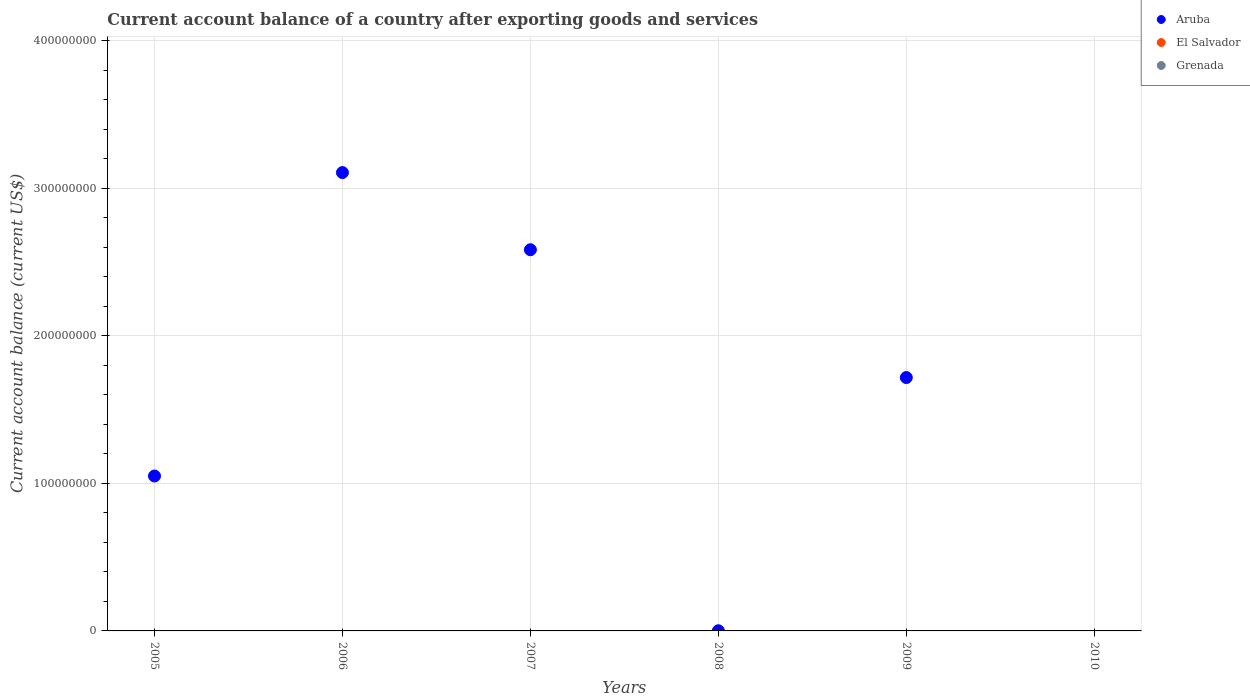Is the number of dotlines equal to the number of legend labels?
Offer a terse response. No. What is the account balance in Aruba in 2008?
Provide a short and direct response. 1.12e+05. Across all years, what is the maximum account balance in Aruba?
Your answer should be very brief. 3.11e+08. Across all years, what is the minimum account balance in El Salvador?
Ensure brevity in your answer.  0. What is the total account balance in Grenada in the graph?
Your answer should be compact. 0. What is the difference between the account balance in Aruba in 2008 and the account balance in El Salvador in 2007?
Give a very brief answer. 1.12e+05. What is the average account balance in Aruba per year?
Make the answer very short. 1.41e+08. In how many years, is the account balance in Grenada greater than 260000000 US$?
Give a very brief answer. 0. What is the ratio of the account balance in Aruba in 2008 to that in 2009?
Your answer should be compact. 0. What is the difference between the highest and the second highest account balance in Aruba?
Provide a short and direct response. 5.23e+07. What is the difference between the highest and the lowest account balance in Aruba?
Offer a terse response. 3.11e+08. Does the account balance in Aruba monotonically increase over the years?
Your answer should be compact. No. Is the account balance in Grenada strictly less than the account balance in Aruba over the years?
Offer a very short reply. No. Does the graph contain grids?
Ensure brevity in your answer.  Yes. How many legend labels are there?
Your answer should be compact. 3. What is the title of the graph?
Make the answer very short. Current account balance of a country after exporting goods and services. What is the label or title of the X-axis?
Ensure brevity in your answer.  Years. What is the label or title of the Y-axis?
Offer a terse response. Current account balance (current US$). What is the Current account balance (current US$) of Aruba in 2005?
Provide a succinct answer. 1.05e+08. What is the Current account balance (current US$) in El Salvador in 2005?
Keep it short and to the point. 0. What is the Current account balance (current US$) of Grenada in 2005?
Provide a succinct answer. 0. What is the Current account balance (current US$) of Aruba in 2006?
Your response must be concise. 3.11e+08. What is the Current account balance (current US$) of El Salvador in 2006?
Your answer should be compact. 0. What is the Current account balance (current US$) of Grenada in 2006?
Give a very brief answer. 0. What is the Current account balance (current US$) in Aruba in 2007?
Your answer should be compact. 2.58e+08. What is the Current account balance (current US$) of Grenada in 2007?
Keep it short and to the point. 0. What is the Current account balance (current US$) in Aruba in 2008?
Provide a succinct answer. 1.12e+05. What is the Current account balance (current US$) in Aruba in 2009?
Keep it short and to the point. 1.72e+08. What is the Current account balance (current US$) in Grenada in 2009?
Your response must be concise. 0. Across all years, what is the maximum Current account balance (current US$) in Aruba?
Provide a succinct answer. 3.11e+08. Across all years, what is the minimum Current account balance (current US$) of Aruba?
Offer a terse response. 0. What is the total Current account balance (current US$) in Aruba in the graph?
Provide a short and direct response. 8.46e+08. What is the total Current account balance (current US$) in Grenada in the graph?
Give a very brief answer. 0. What is the difference between the Current account balance (current US$) of Aruba in 2005 and that in 2006?
Provide a succinct answer. -2.06e+08. What is the difference between the Current account balance (current US$) in Aruba in 2005 and that in 2007?
Provide a short and direct response. -1.53e+08. What is the difference between the Current account balance (current US$) of Aruba in 2005 and that in 2008?
Keep it short and to the point. 1.05e+08. What is the difference between the Current account balance (current US$) in Aruba in 2005 and that in 2009?
Ensure brevity in your answer.  -6.67e+07. What is the difference between the Current account balance (current US$) of Aruba in 2006 and that in 2007?
Keep it short and to the point. 5.23e+07. What is the difference between the Current account balance (current US$) in Aruba in 2006 and that in 2008?
Make the answer very short. 3.10e+08. What is the difference between the Current account balance (current US$) in Aruba in 2006 and that in 2009?
Your answer should be very brief. 1.39e+08. What is the difference between the Current account balance (current US$) of Aruba in 2007 and that in 2008?
Keep it short and to the point. 2.58e+08. What is the difference between the Current account balance (current US$) in Aruba in 2007 and that in 2009?
Keep it short and to the point. 8.66e+07. What is the difference between the Current account balance (current US$) of Aruba in 2008 and that in 2009?
Provide a succinct answer. -1.72e+08. What is the average Current account balance (current US$) of Aruba per year?
Keep it short and to the point. 1.41e+08. What is the average Current account balance (current US$) of Grenada per year?
Keep it short and to the point. 0. What is the ratio of the Current account balance (current US$) of Aruba in 2005 to that in 2006?
Provide a succinct answer. 0.34. What is the ratio of the Current account balance (current US$) in Aruba in 2005 to that in 2007?
Offer a terse response. 0.41. What is the ratio of the Current account balance (current US$) of Aruba in 2005 to that in 2008?
Provide a succinct answer. 939.42. What is the ratio of the Current account balance (current US$) in Aruba in 2005 to that in 2009?
Ensure brevity in your answer.  0.61. What is the ratio of the Current account balance (current US$) in Aruba in 2006 to that in 2007?
Provide a succinct answer. 1.2. What is the ratio of the Current account balance (current US$) in Aruba in 2006 to that in 2008?
Give a very brief answer. 2779.47. What is the ratio of the Current account balance (current US$) in Aruba in 2006 to that in 2009?
Ensure brevity in your answer.  1.81. What is the ratio of the Current account balance (current US$) in Aruba in 2007 to that in 2008?
Give a very brief answer. 2311.5. What is the ratio of the Current account balance (current US$) in Aruba in 2007 to that in 2009?
Offer a very short reply. 1.5. What is the ratio of the Current account balance (current US$) of Aruba in 2008 to that in 2009?
Your response must be concise. 0. What is the difference between the highest and the second highest Current account balance (current US$) in Aruba?
Keep it short and to the point. 5.23e+07. What is the difference between the highest and the lowest Current account balance (current US$) of Aruba?
Your answer should be compact. 3.11e+08. 